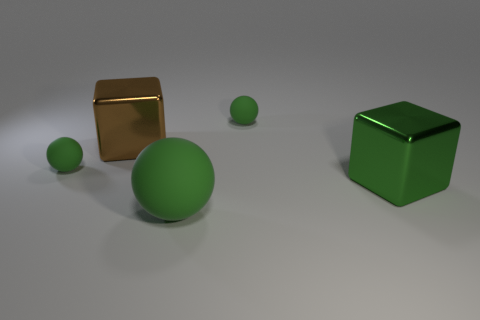Do the brown thing and the green metallic thing have the same size?
Your answer should be very brief. Yes. There is a big block that is left of the large green thing behind the large ball in front of the brown shiny thing; what is its color?
Offer a terse response. Brown. How many small spheres have the same color as the big ball?
Make the answer very short. 2. What number of big objects are gray matte spheres or green cubes?
Give a very brief answer. 1. Is there another shiny object that has the same shape as the green metallic object?
Ensure brevity in your answer.  Yes. Do the brown object and the green metallic thing have the same shape?
Keep it short and to the point. Yes. The matte object that is in front of the tiny green ball that is to the left of the big rubber ball is what color?
Offer a terse response. Green. What is the color of the other cube that is the same size as the green metallic block?
Your answer should be compact. Brown. How many metal objects are tiny green blocks or big brown things?
Offer a terse response. 1. There is a small ball behind the big brown object; how many tiny objects are behind it?
Provide a short and direct response. 0. 